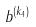Convert formula to latex. <formula><loc_0><loc_0><loc_500><loc_500>b ^ { ( k _ { 4 } ) }</formula> 